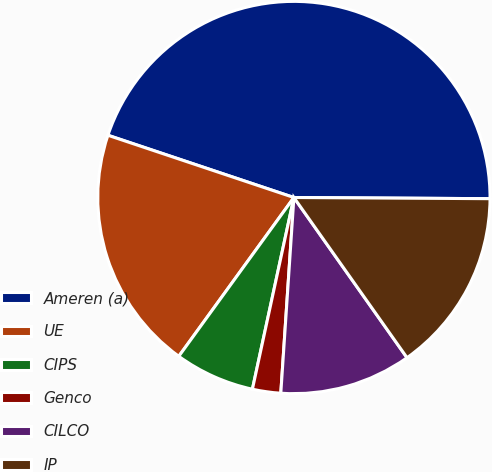<chart> <loc_0><loc_0><loc_500><loc_500><pie_chart><fcel>Ameren (a)<fcel>UE<fcel>CIPS<fcel>Genco<fcel>CILCO<fcel>IP<nl><fcel>44.96%<fcel>20.16%<fcel>6.59%<fcel>2.33%<fcel>10.85%<fcel>15.12%<nl></chart> 